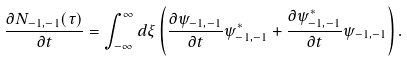Convert formula to latex. <formula><loc_0><loc_0><loc_500><loc_500>\frac { \partial N _ { - 1 , - 1 } ( \tau ) } { \partial t } = \int _ { - \infty } ^ { \infty } d \xi \left ( \frac { \partial \psi _ { - 1 , - 1 } } { \partial t } \psi _ { - 1 , - 1 } ^ { * } + \frac { \partial \psi _ { - 1 , - 1 } ^ { * } } { \partial t } \psi _ { - 1 , - 1 } \right ) .</formula> 